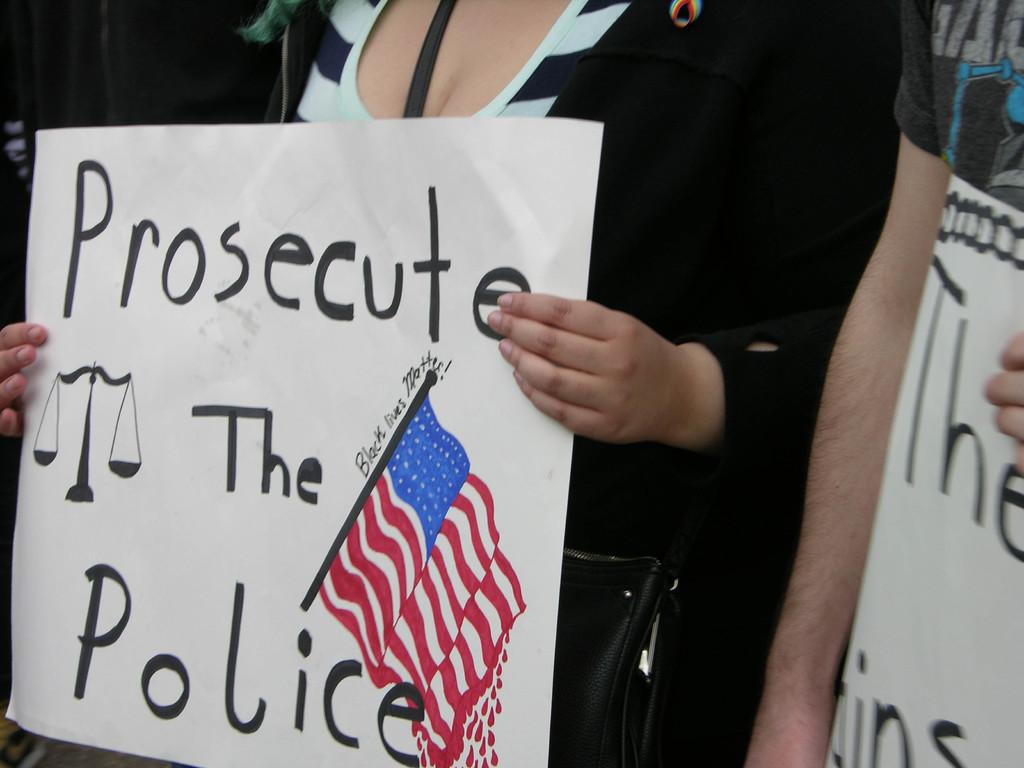<image>
Describe the image concisely. A woman holds a sign that says, "Prosecute the Police". 